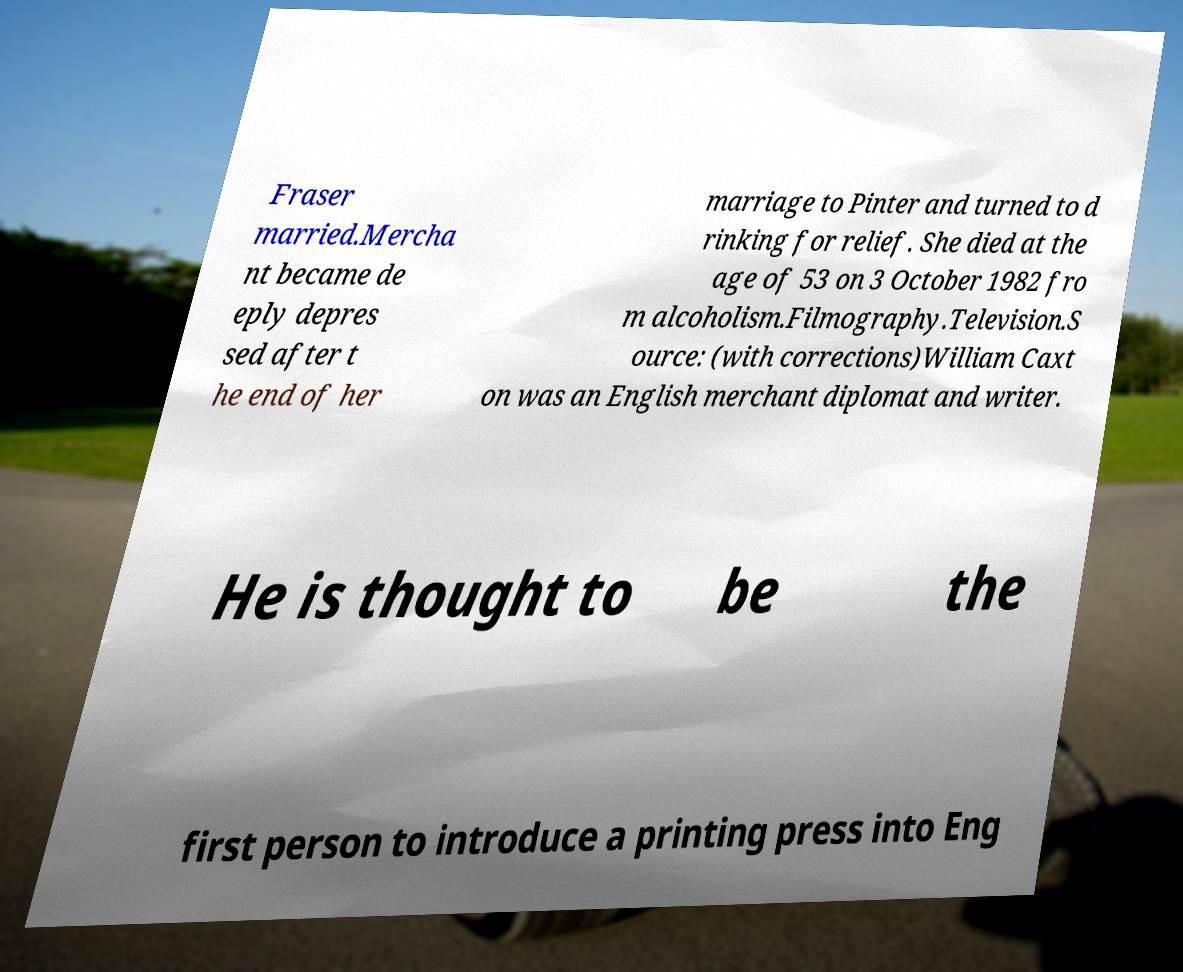Please identify and transcribe the text found in this image. Fraser married.Mercha nt became de eply depres sed after t he end of her marriage to Pinter and turned to d rinking for relief. She died at the age of 53 on 3 October 1982 fro m alcoholism.Filmography.Television.S ource: (with corrections)William Caxt on was an English merchant diplomat and writer. He is thought to be the first person to introduce a printing press into Eng 